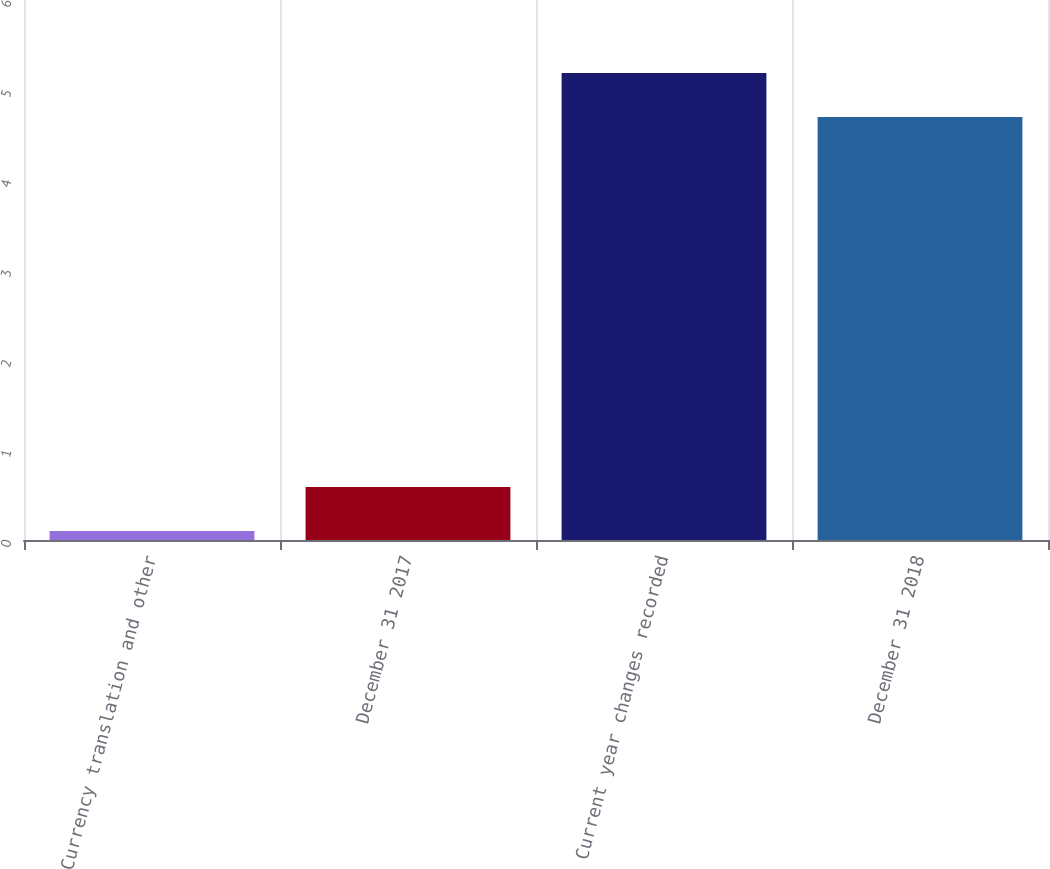Convert chart. <chart><loc_0><loc_0><loc_500><loc_500><bar_chart><fcel>Currency translation and other<fcel>December 31 2017<fcel>Current year changes recorded<fcel>December 31 2018<nl><fcel>0.1<fcel>0.59<fcel>5.19<fcel>4.7<nl></chart> 